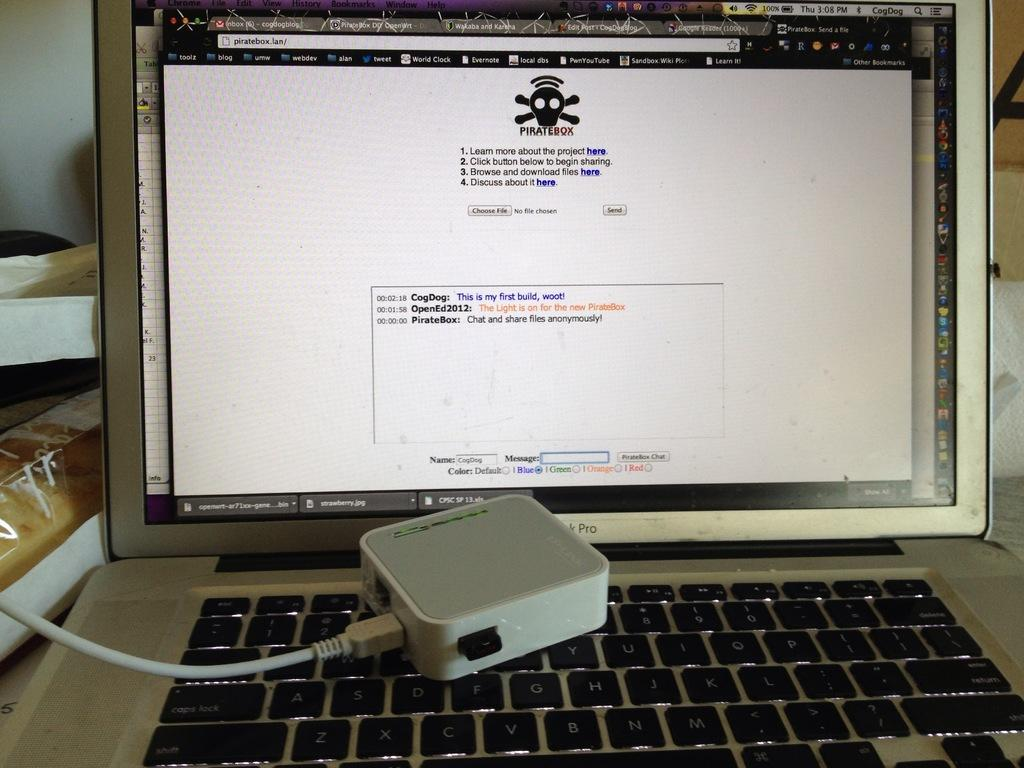<image>
Create a compact narrative representing the image presented. A website names pirate box is open with a small box laying on a laptop keyboard. 